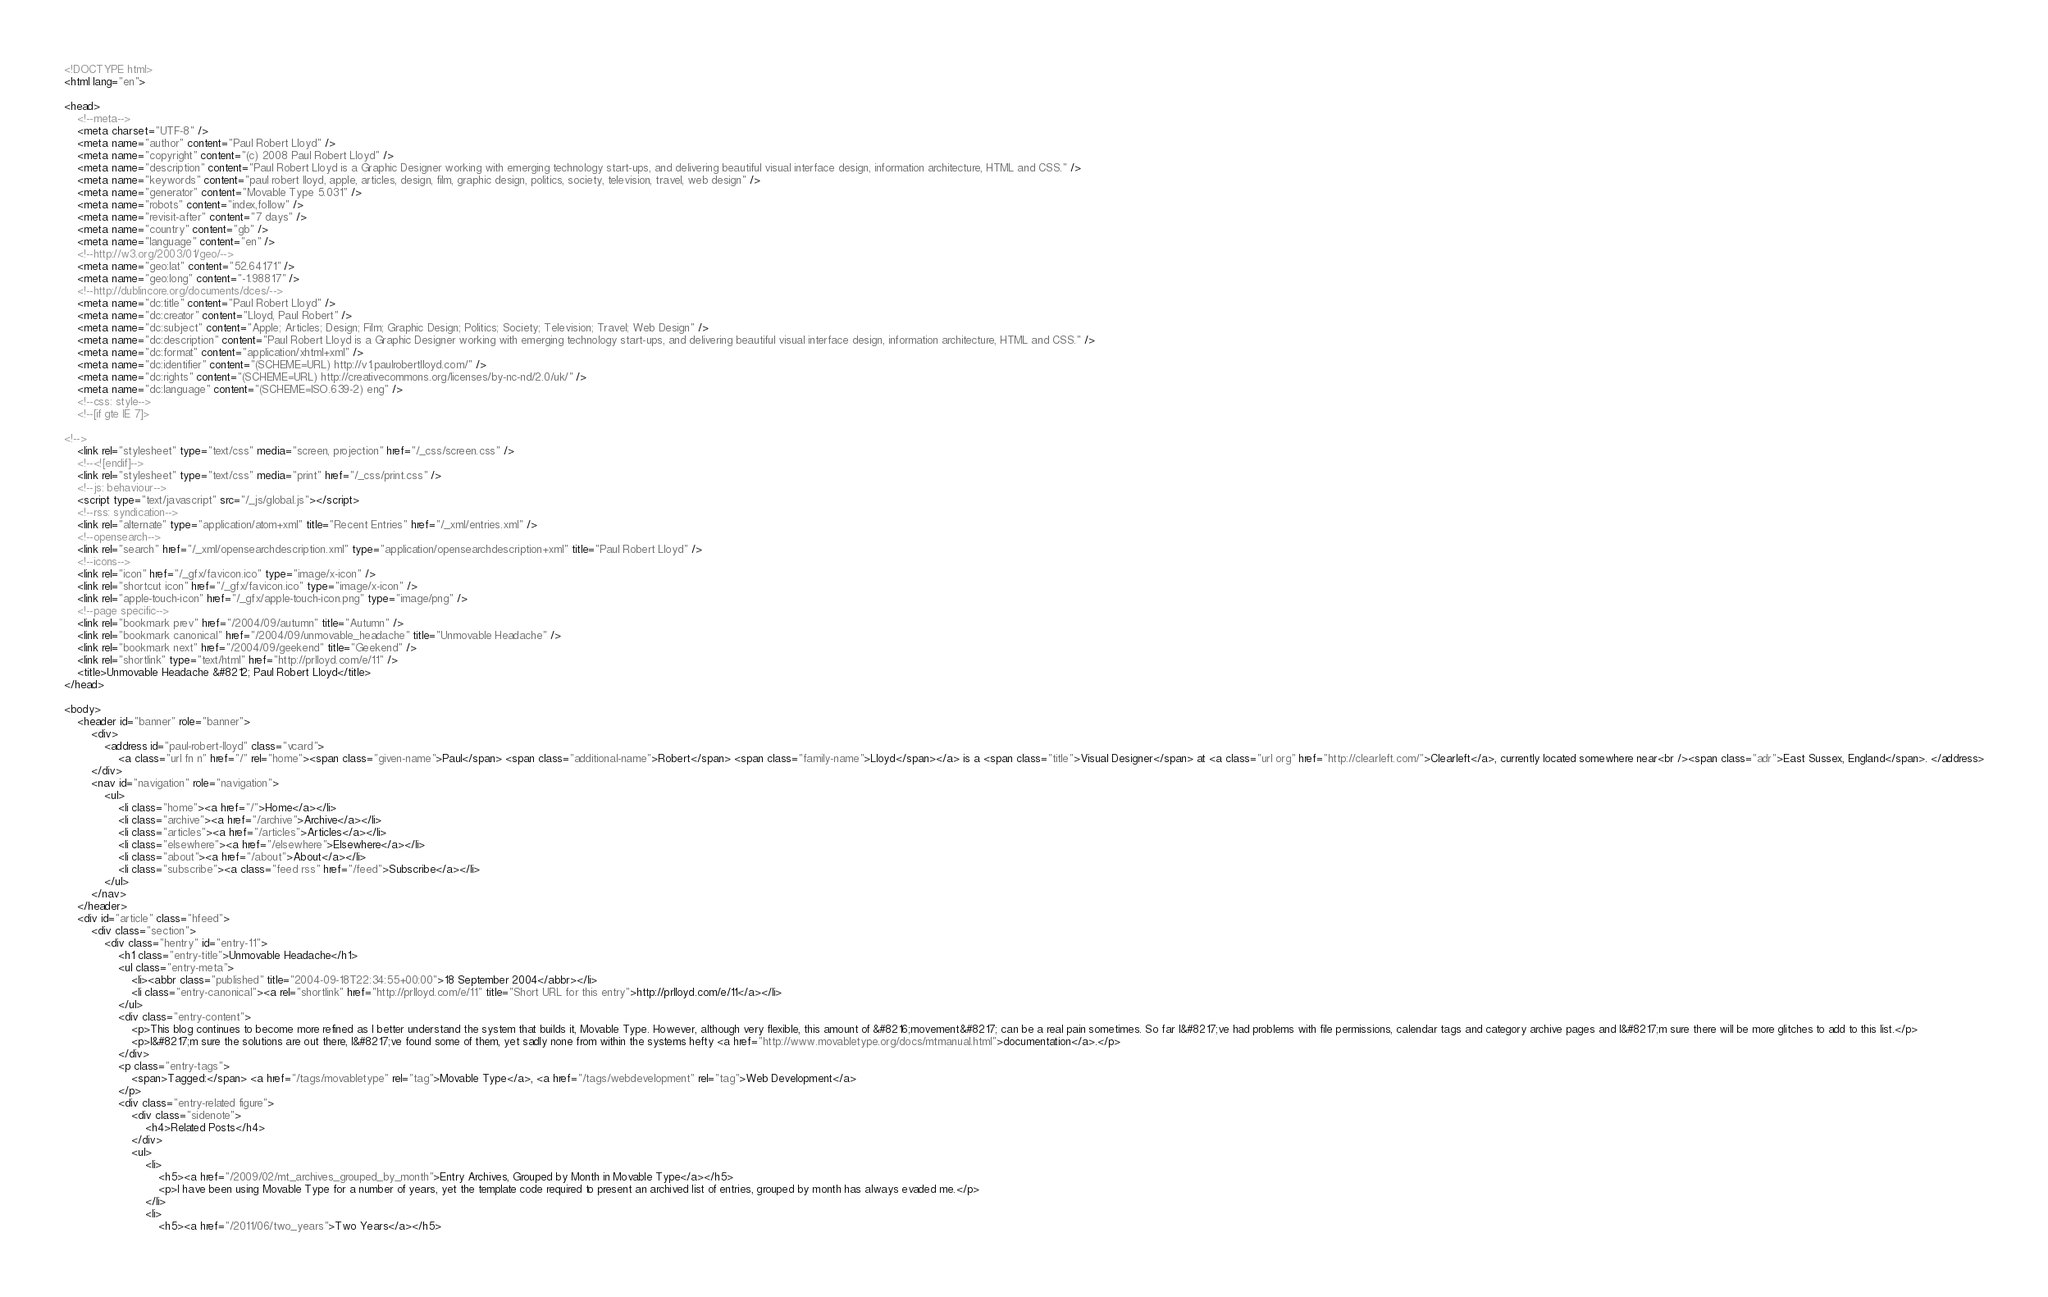<code> <loc_0><loc_0><loc_500><loc_500><_HTML_><!DOCTYPE html>
<html lang="en">

<head>
    <!--meta-->
    <meta charset="UTF-8" />
    <meta name="author" content="Paul Robert Lloyd" />
    <meta name="copyright" content="(c) 2008 Paul Robert Lloyd" />
    <meta name="description" content="Paul Robert Lloyd is a Graphic Designer working with emerging technology start-ups, and delivering beautiful visual interface design, information architecture, HTML and CSS." />
    <meta name="keywords" content="paul robert lloyd, apple, articles, design, film, graphic design, politics, society, television, travel, web design" />
    <meta name="generator" content="Movable Type 5.031" />
    <meta name="robots" content="index,follow" />
    <meta name="revisit-after" content="7 days" />
    <meta name="country" content="gb" />
    <meta name="language" content="en" />
    <!--http://w3.org/2003/01/geo/-->
    <meta name="geo:lat" content="52.64171" />
    <meta name="geo:long" content="-1.98817" />
    <!--http://dublincore.org/documents/dces/-->
    <meta name="dc:title" content="Paul Robert Lloyd" />
    <meta name="dc:creator" content="Lloyd, Paul Robert" />
    <meta name="dc:subject" content="Apple; Articles; Design; Film; Graphic Design; Politics; Society; Television; Travel; Web Design" />
    <meta name="dc:description" content="Paul Robert Lloyd is a Graphic Designer working with emerging technology start-ups, and delivering beautiful visual interface design, information architecture, HTML and CSS." />
    <meta name="dc:format" content="application/xhtml+xml" />
    <meta name="dc:identifier" content="(SCHEME=URL) http://v1.paulrobertlloyd.com/" />
    <meta name="dc:rights" content="(SCHEME=URL) http://creativecommons.org/licenses/by-nc-nd/2.0/uk/" />
    <meta name="dc:language" content="(SCHEME=ISO.639-2) eng" />
    <!--css: style-->
    <!--[if gte IE 7]>

<!-->
    <link rel="stylesheet" type="text/css" media="screen, projection" href="/_css/screen.css" />
    <!--<![endif]-->
    <link rel="stylesheet" type="text/css" media="print" href="/_css/print.css" />
    <!--js: behaviour-->
    <script type="text/javascript" src="/_js/global.js"></script>
    <!--rss: syndication-->
    <link rel="alternate" type="application/atom+xml" title="Recent Entries" href="/_xml/entries.xml" />
    <!--opensearch-->
    <link rel="search" href="/_xml/opensearchdescription.xml" type="application/opensearchdescription+xml" title="Paul Robert Lloyd" />
    <!--icons-->
    <link rel="icon" href="/_gfx/favicon.ico" type="image/x-icon" />
    <link rel="shortcut icon" href="/_gfx/favicon.ico" type="image/x-icon" />
    <link rel="apple-touch-icon" href="/_gfx/apple-touch-icon.png" type="image/png" />
    <!--page specific-->
    <link rel="bookmark prev" href="/2004/09/autumn" title="Autumn" />
    <link rel="bookmark canonical" href="/2004/09/unmovable_headache" title="Unmovable Headache" />
    <link rel="bookmark next" href="/2004/09/geekend" title="Geekend" />
    <link rel="shortlink" type="text/html" href="http://prlloyd.com/e/11" />
    <title>Unmovable Headache &#8212; Paul Robert Lloyd</title>
</head>

<body>
    <header id="banner" role="banner">
        <div>
            <address id="paul-robert-lloyd" class="vcard">
                <a class="url fn n" href="/" rel="home"><span class="given-name">Paul</span> <span class="additional-name">Robert</span> <span class="family-name">Lloyd</span></a> is a <span class="title">Visual Designer</span> at <a class="url org" href="http://clearleft.com/">Clearleft</a>, currently located somewhere near<br /><span class="adr">East Sussex, England</span>. </address>
        </div>
        <nav id="navigation" role="navigation">
            <ul>
                <li class="home"><a href="/">Home</a></li>
                <li class="archive"><a href="/archive">Archive</a></li>
                <li class="articles"><a href="/articles">Articles</a></li>
                <li class="elsewhere"><a href="/elsewhere">Elsewhere</a></li>
                <li class="about"><a href="/about">About</a></li>
                <li class="subscribe"><a class="feed rss" href="/feed">Subscribe</a></li>
            </ul>
        </nav>
    </header>
    <div id="article" class="hfeed">
        <div class="section">
            <div class="hentry" id="entry-11">
                <h1 class="entry-title">Unmovable Headache</h1>
                <ul class="entry-meta">
                    <li><abbr class="published" title="2004-09-18T22:34:55+00:00">18 September 2004</abbr></li>
                    <li class="entry-canonical"><a rel="shortlink" href="http://prlloyd.com/e/11" title="Short URL for this entry">http://prlloyd.com/e/11</a></li>
                </ul>
                <div class="entry-content">
                    <p>This blog continues to become more refined as I better understand the system that builds it, Movable Type. However, although very flexible, this amount of &#8216;movement&#8217; can be a real pain sometimes. So far I&#8217;ve had problems with file permissions, calendar tags and category archive pages and I&#8217;m sure there will be more glitches to add to this list.</p>
                    <p>I&#8217;m sure the solutions are out there, I&#8217;ve found some of them, yet sadly none from within the systems hefty <a href="http://www.movabletype.org/docs/mtmanual.html">documentation</a>.</p>
                </div>
                <p class="entry-tags">
                    <span>Tagged:</span> <a href="/tags/movabletype" rel="tag">Movable Type</a>, <a href="/tags/webdevelopment" rel="tag">Web Development</a>
                </p>
                <div class="entry-related figure">
                    <div class="sidenote">
                        <h4>Related Posts</h4>
                    </div>
                    <ul>
                        <li>
                            <h5><a href="/2009/02/mt_archives_grouped_by_month">Entry Archives, Grouped by Month in Movable Type</a></h5>
                            <p>I have been using Movable Type for a number of years, yet the template code required to present an archived list of entries, grouped by month has always evaded me.</p>
                        </li>
                        <li>
                            <h5><a href="/2011/06/two_years">Two Years</a></h5></code> 